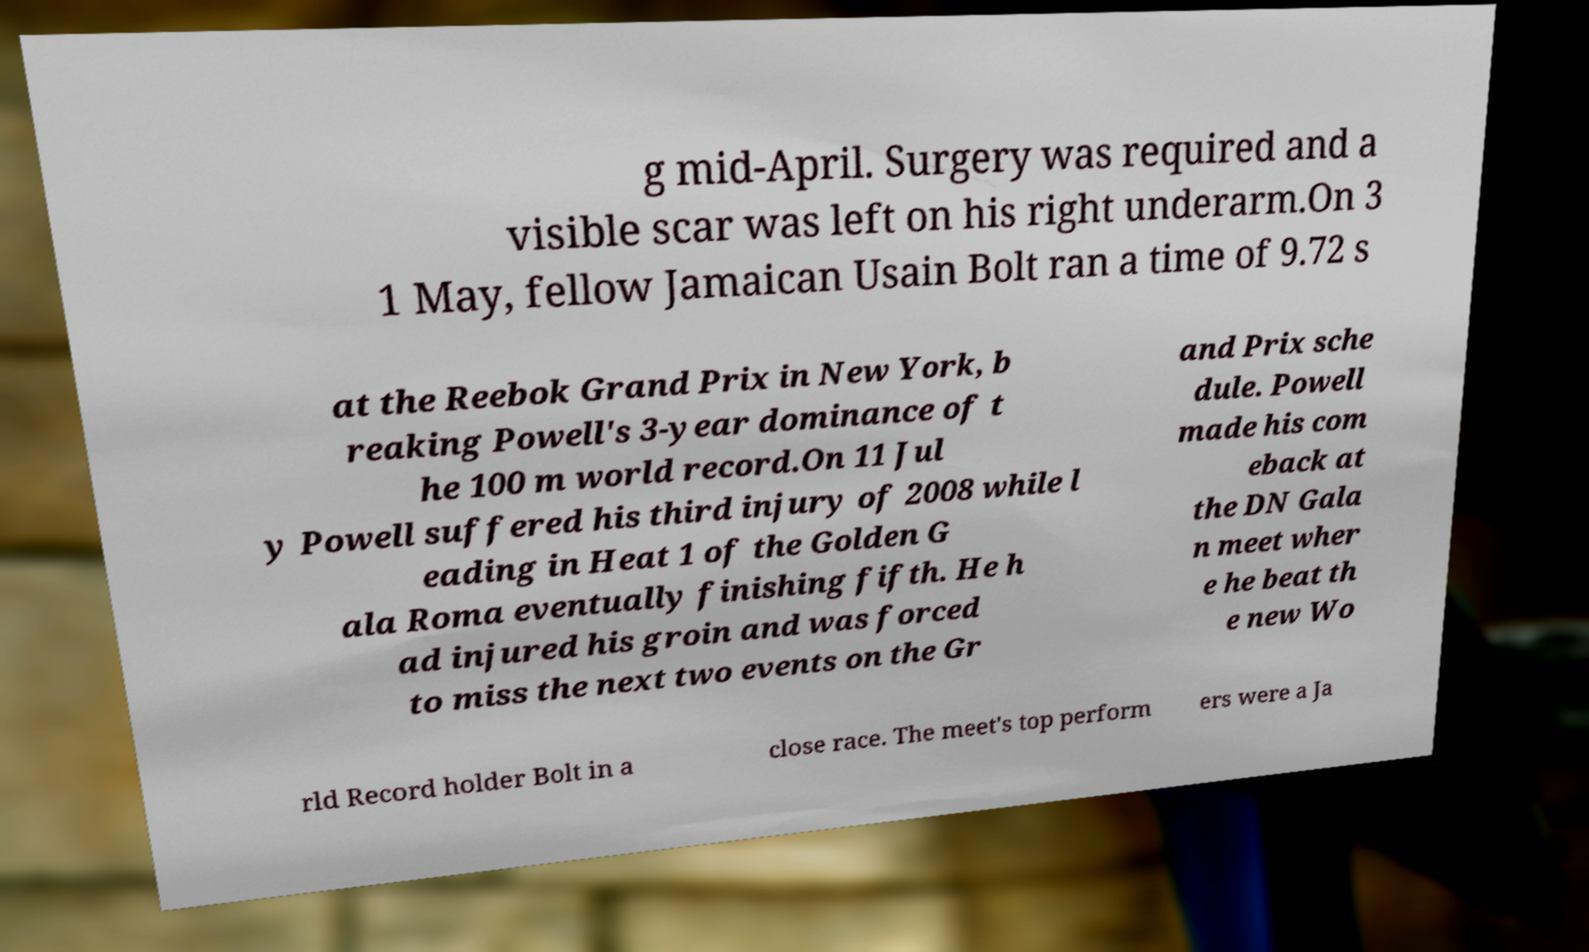Can you accurately transcribe the text from the provided image for me? g mid-April. Surgery was required and a visible scar was left on his right underarm.On 3 1 May, fellow Jamaican Usain Bolt ran a time of 9.72 s at the Reebok Grand Prix in New York, b reaking Powell's 3-year dominance of t he 100 m world record.On 11 Jul y Powell suffered his third injury of 2008 while l eading in Heat 1 of the Golden G ala Roma eventually finishing fifth. He h ad injured his groin and was forced to miss the next two events on the Gr and Prix sche dule. Powell made his com eback at the DN Gala n meet wher e he beat th e new Wo rld Record holder Bolt in a close race. The meet's top perform ers were a Ja 